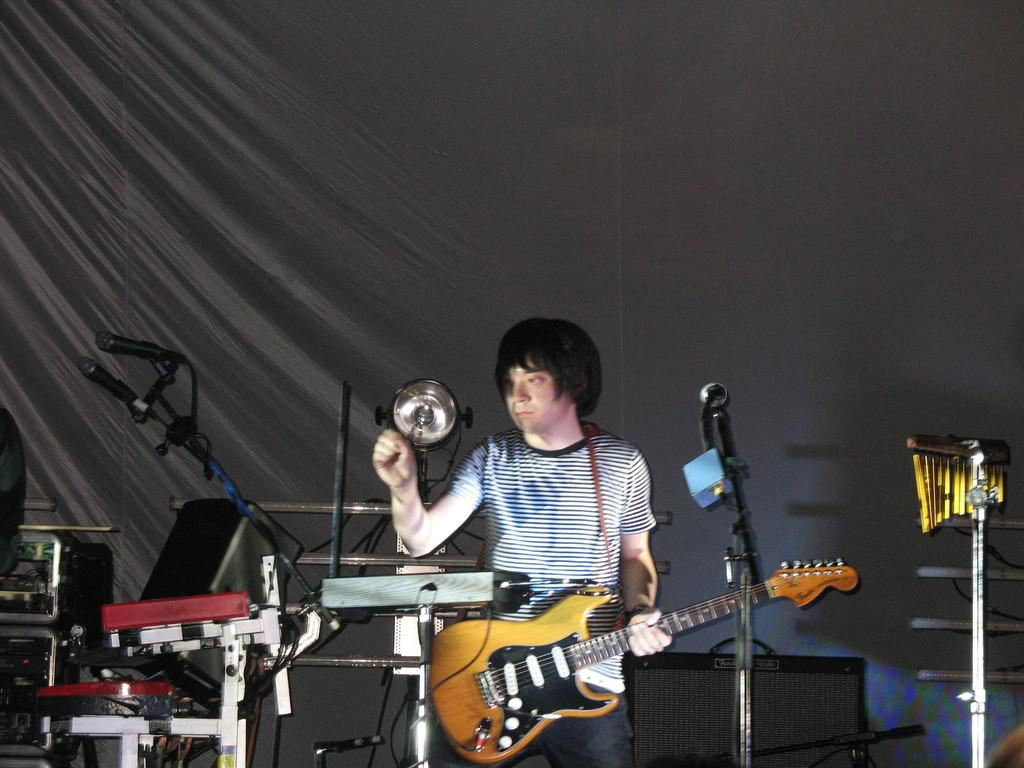What can be seen in the background of the image? There is a black cloth in the background of the image. What is the person in the image doing? The person is standing in front of a microphone and holding a guitar. Can you describe the lighting in the image? There is a light visible in the image. How many microphones are present in the image? There are microphones present in the image. What type of steel is used to construct the airplane in the image? There is no airplane present in the image; it features a person standing in front of a microphone and holding a guitar. What word is being sung by the person in the image? The image does not provide any information about the words being sung, as it only shows a person holding a guitar and standing near a microphone. 